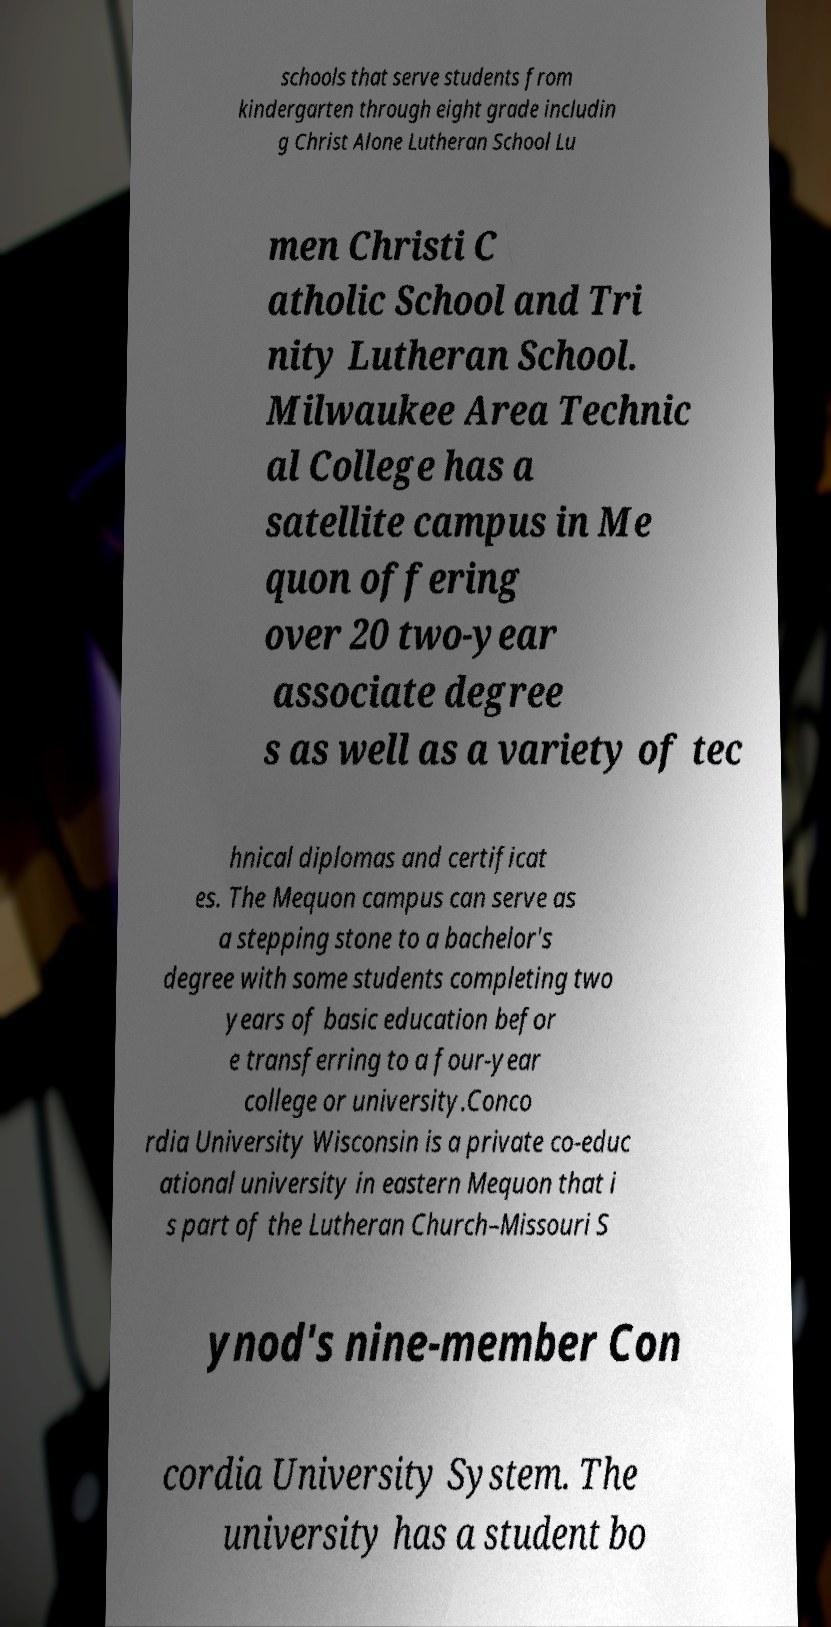Can you accurately transcribe the text from the provided image for me? schools that serve students from kindergarten through eight grade includin g Christ Alone Lutheran School Lu men Christi C atholic School and Tri nity Lutheran School. Milwaukee Area Technic al College has a satellite campus in Me quon offering over 20 two-year associate degree s as well as a variety of tec hnical diplomas and certificat es. The Mequon campus can serve as a stepping stone to a bachelor's degree with some students completing two years of basic education befor e transferring to a four-year college or university.Conco rdia University Wisconsin is a private co-educ ational university in eastern Mequon that i s part of the Lutheran Church–Missouri S ynod's nine-member Con cordia University System. The university has a student bo 